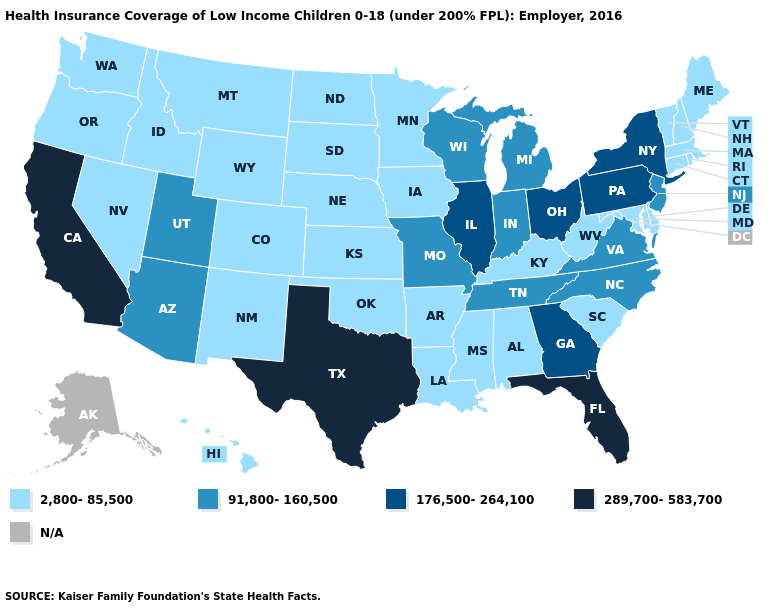What is the lowest value in the MidWest?
Write a very short answer. 2,800-85,500. What is the lowest value in states that border Ohio?
Concise answer only. 2,800-85,500. What is the value of Arizona?
Answer briefly. 91,800-160,500. What is the lowest value in the West?
Be succinct. 2,800-85,500. Which states have the lowest value in the USA?
Keep it brief. Alabama, Arkansas, Colorado, Connecticut, Delaware, Hawaii, Idaho, Iowa, Kansas, Kentucky, Louisiana, Maine, Maryland, Massachusetts, Minnesota, Mississippi, Montana, Nebraska, Nevada, New Hampshire, New Mexico, North Dakota, Oklahoma, Oregon, Rhode Island, South Carolina, South Dakota, Vermont, Washington, West Virginia, Wyoming. Does the first symbol in the legend represent the smallest category?
Short answer required. Yes. What is the value of Mississippi?
Keep it brief. 2,800-85,500. Name the states that have a value in the range 289,700-583,700?
Keep it brief. California, Florida, Texas. What is the value of Nebraska?
Write a very short answer. 2,800-85,500. What is the highest value in states that border Arizona?
Be succinct. 289,700-583,700. Does South Carolina have the highest value in the South?
Keep it brief. No. Name the states that have a value in the range 2,800-85,500?
Write a very short answer. Alabama, Arkansas, Colorado, Connecticut, Delaware, Hawaii, Idaho, Iowa, Kansas, Kentucky, Louisiana, Maine, Maryland, Massachusetts, Minnesota, Mississippi, Montana, Nebraska, Nevada, New Hampshire, New Mexico, North Dakota, Oklahoma, Oregon, Rhode Island, South Carolina, South Dakota, Vermont, Washington, West Virginia, Wyoming. What is the highest value in the South ?
Answer briefly. 289,700-583,700. What is the value of New Hampshire?
Answer briefly. 2,800-85,500. 